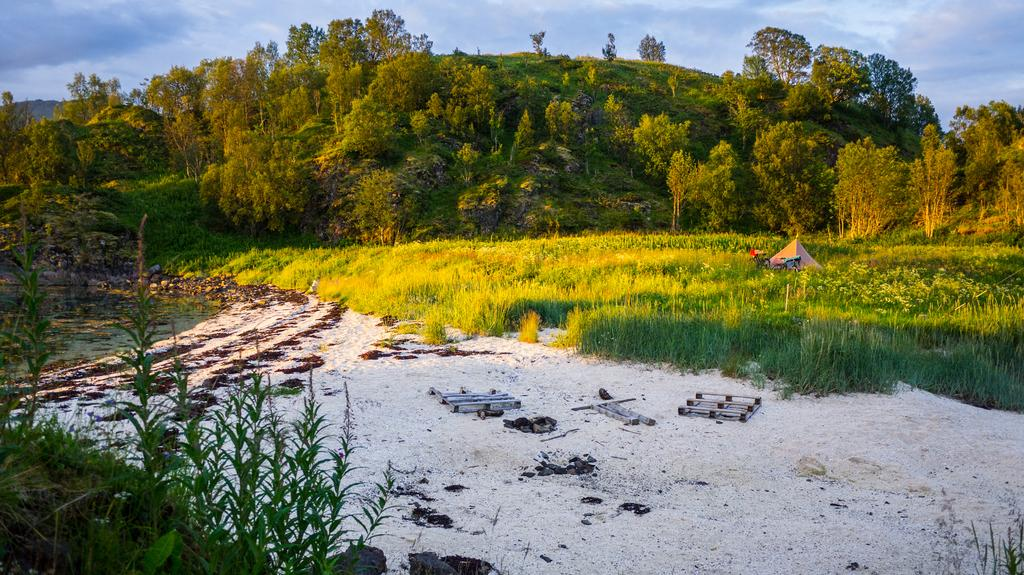What type of living organisms can be seen in the image? Plants can be seen in the image. What is on the ground in the image? There are objects on the ground in the image. What is the primary element visible in the image? Water is visible in the image. What can be seen in the background of the image? Trees and the sky are visible in the background of the image. How many sheep are visible in the image? There are no sheep present in the image. What type of body is shown interacting with the plants in the image? There is no body shown interacting with the plants in the image; only plants, objects, water, trees, and the sky are present. 